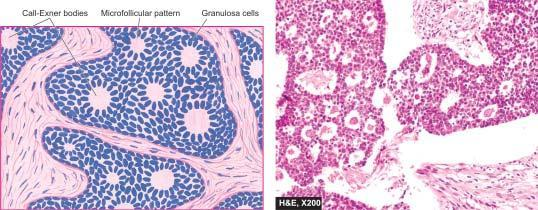s the opened up inner surface of the abdominal aorta surrounded by granulosa cells?
Answer the question using a single word or phrase. No 